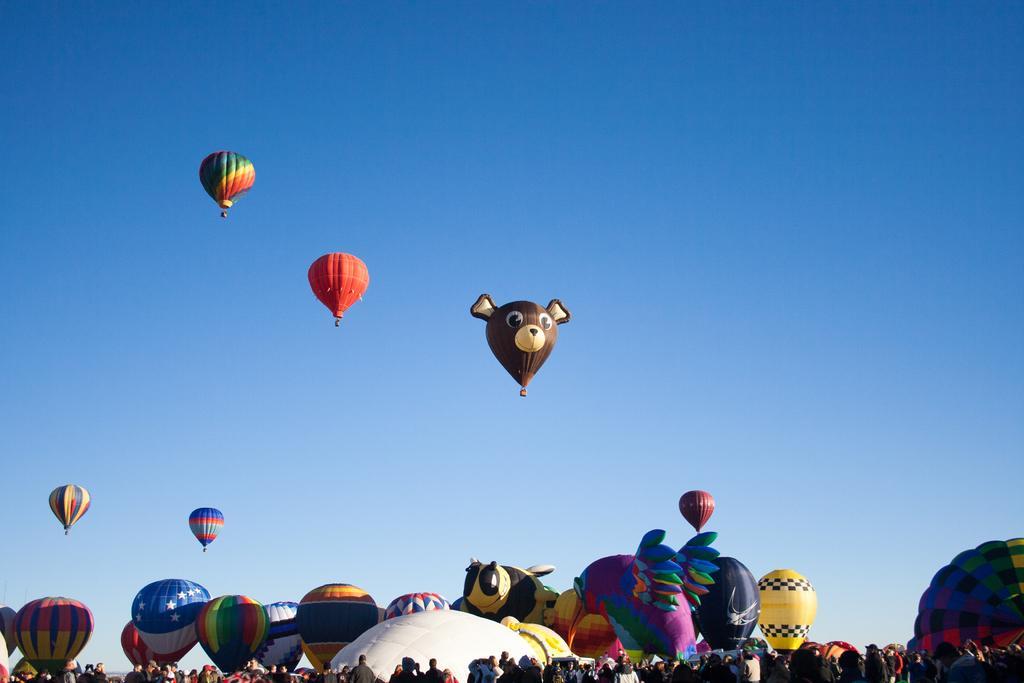Can you describe this image briefly? In this image I can see at the bottom there are people, in the middle there are hot air balloons, at the top it is the sky. 